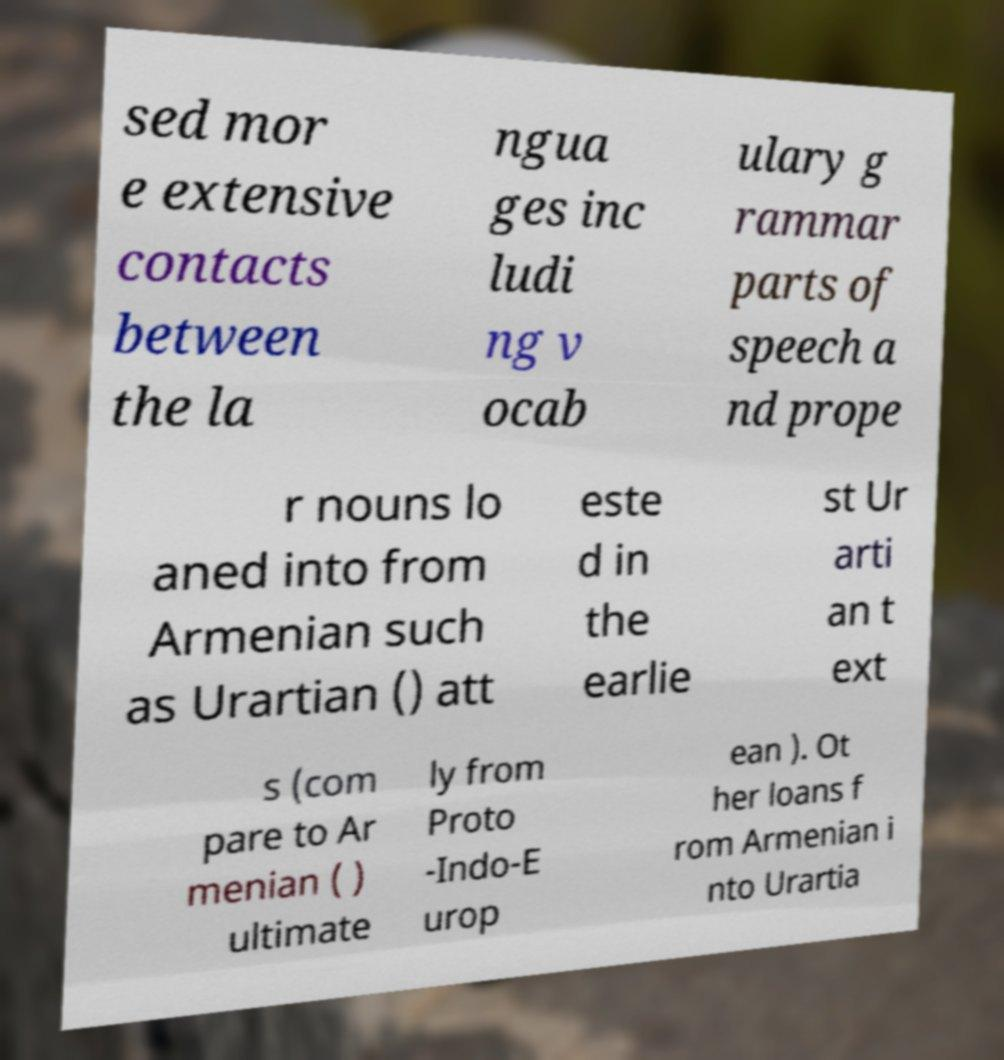There's text embedded in this image that I need extracted. Can you transcribe it verbatim? sed mor e extensive contacts between the la ngua ges inc ludi ng v ocab ulary g rammar parts of speech a nd prope r nouns lo aned into from Armenian such as Urartian () att este d in the earlie st Ur arti an t ext s (com pare to Ar menian ( ) ultimate ly from Proto -Indo-E urop ean ). Ot her loans f rom Armenian i nto Urartia 